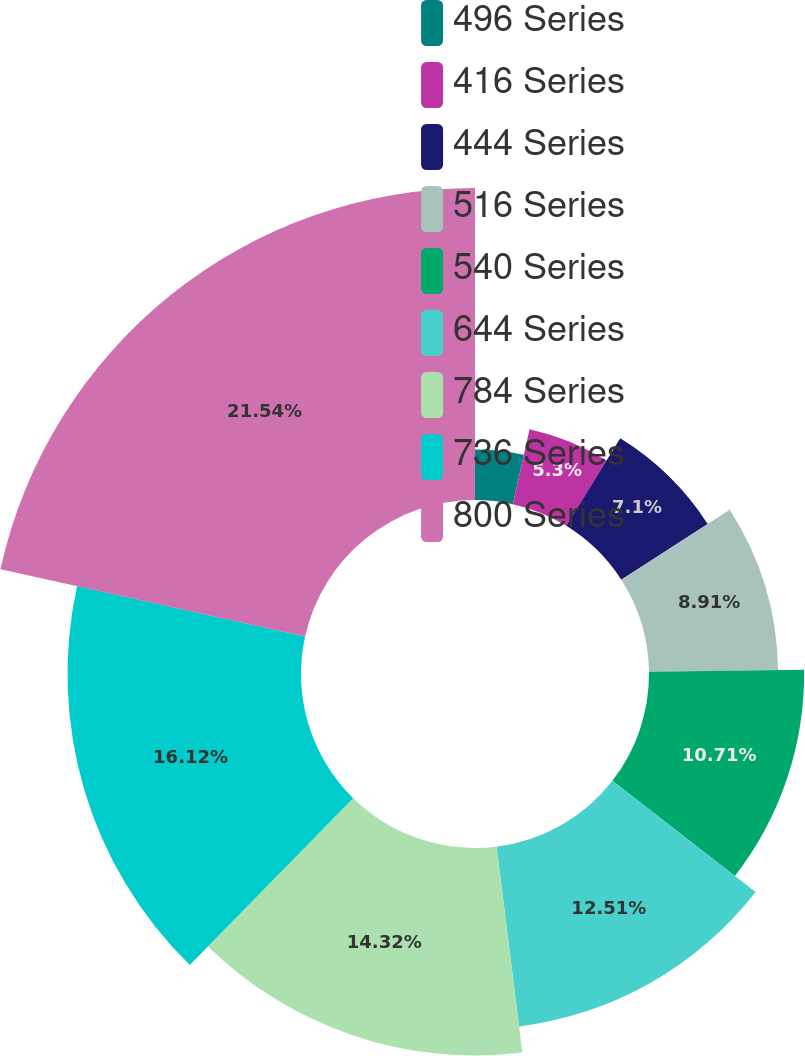Convert chart. <chart><loc_0><loc_0><loc_500><loc_500><pie_chart><fcel>496 Series<fcel>416 Series<fcel>444 Series<fcel>516 Series<fcel>540 Series<fcel>644 Series<fcel>784 Series<fcel>736 Series<fcel>800 Series<nl><fcel>3.49%<fcel>5.3%<fcel>7.1%<fcel>8.91%<fcel>10.71%<fcel>12.51%<fcel>14.32%<fcel>16.12%<fcel>21.54%<nl></chart> 